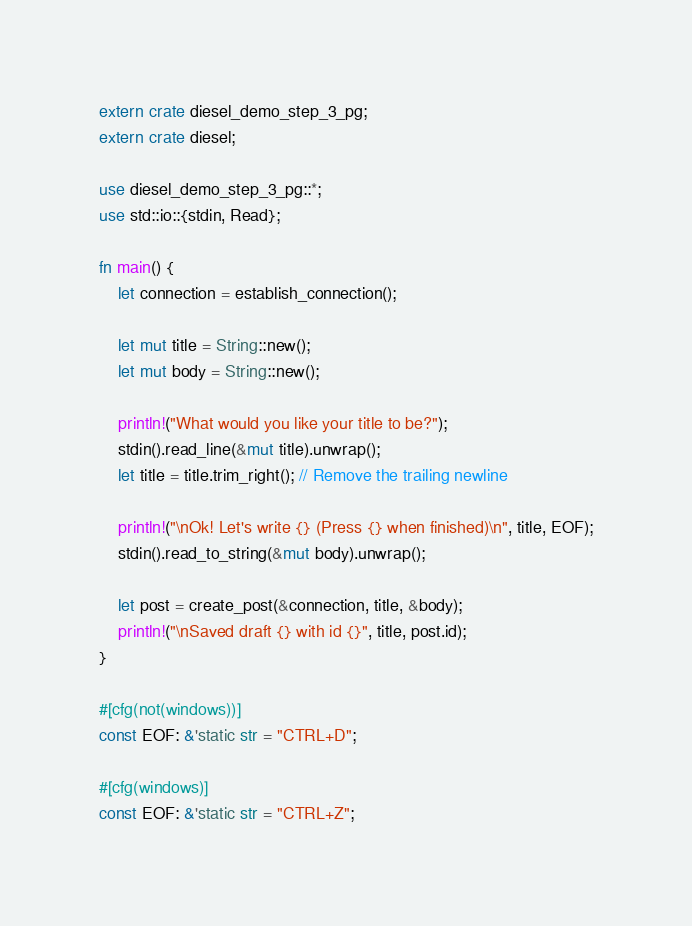Convert code to text. <code><loc_0><loc_0><loc_500><loc_500><_Rust_>extern crate diesel_demo_step_3_pg;
extern crate diesel;

use diesel_demo_step_3_pg::*;
use std::io::{stdin, Read};

fn main() {
    let connection = establish_connection();

    let mut title = String::new();
    let mut body = String::new();

    println!("What would you like your title to be?");
    stdin().read_line(&mut title).unwrap();
    let title = title.trim_right(); // Remove the trailing newline

    println!("\nOk! Let's write {} (Press {} when finished)\n", title, EOF);
    stdin().read_to_string(&mut body).unwrap();

    let post = create_post(&connection, title, &body);
    println!("\nSaved draft {} with id {}", title, post.id);
}

#[cfg(not(windows))]
const EOF: &'static str = "CTRL+D";

#[cfg(windows)]
const EOF: &'static str = "CTRL+Z";
</code> 